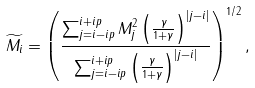Convert formula to latex. <formula><loc_0><loc_0><loc_500><loc_500>\widetilde { M _ { i } } = \left ( \frac { \sum _ { j = i - i p } ^ { i + i p } M _ { j } ^ { 2 } \left ( \frac { \gamma } { 1 + \gamma } \right ) ^ { | j - i | } } { \sum _ { j = i - i p } ^ { i + i p } \left ( \frac { \gamma } { 1 + \gamma } \right ) ^ { | j - i | } } \right ) ^ { 1 / 2 } ,</formula> 